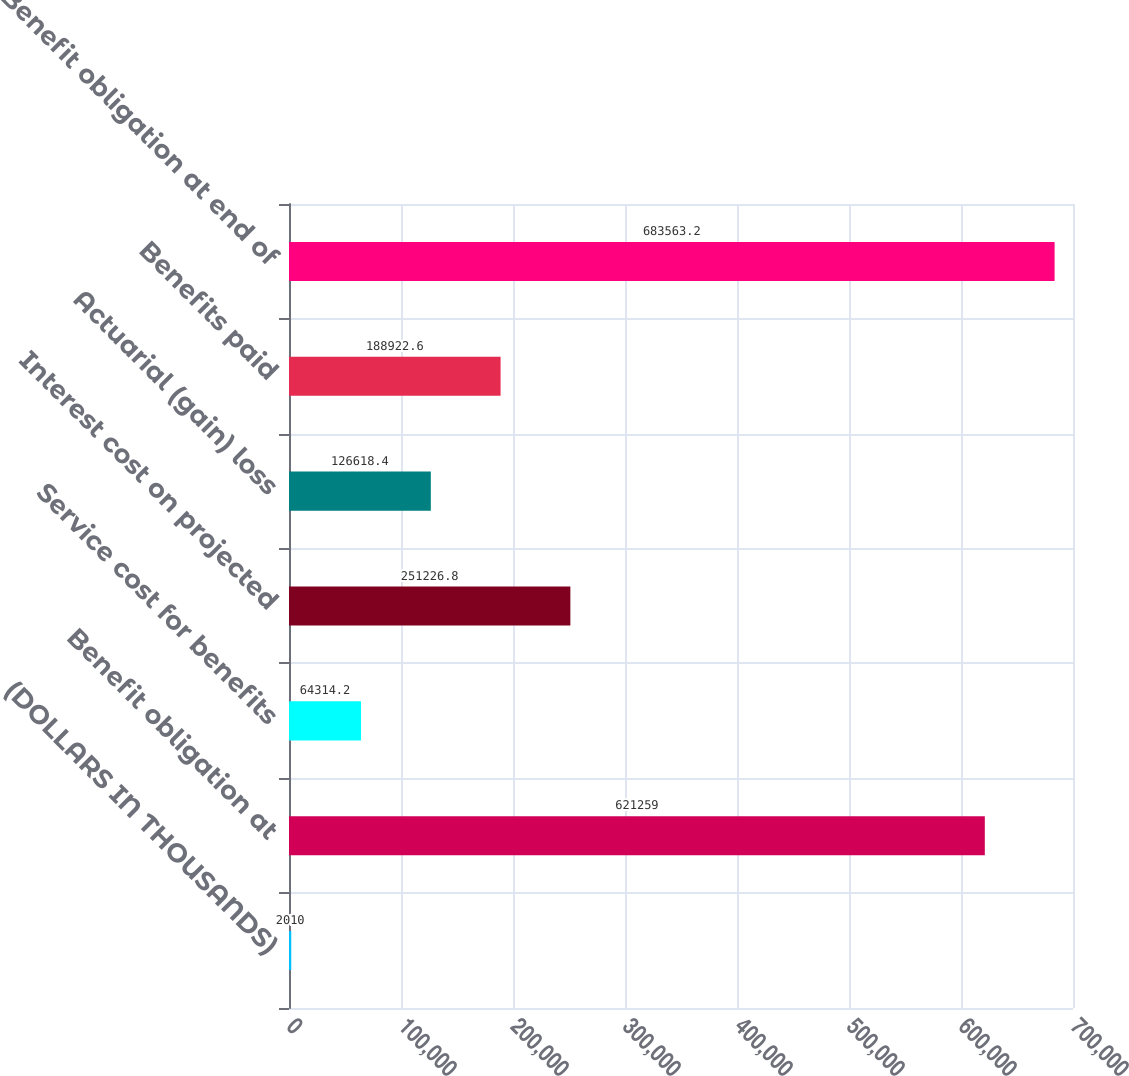<chart> <loc_0><loc_0><loc_500><loc_500><bar_chart><fcel>(DOLLARS IN THOUSANDS)<fcel>Benefit obligation at<fcel>Service cost for benefits<fcel>Interest cost on projected<fcel>Actuarial (gain) loss<fcel>Benefits paid<fcel>Benefit obligation at end of<nl><fcel>2010<fcel>621259<fcel>64314.2<fcel>251227<fcel>126618<fcel>188923<fcel>683563<nl></chart> 